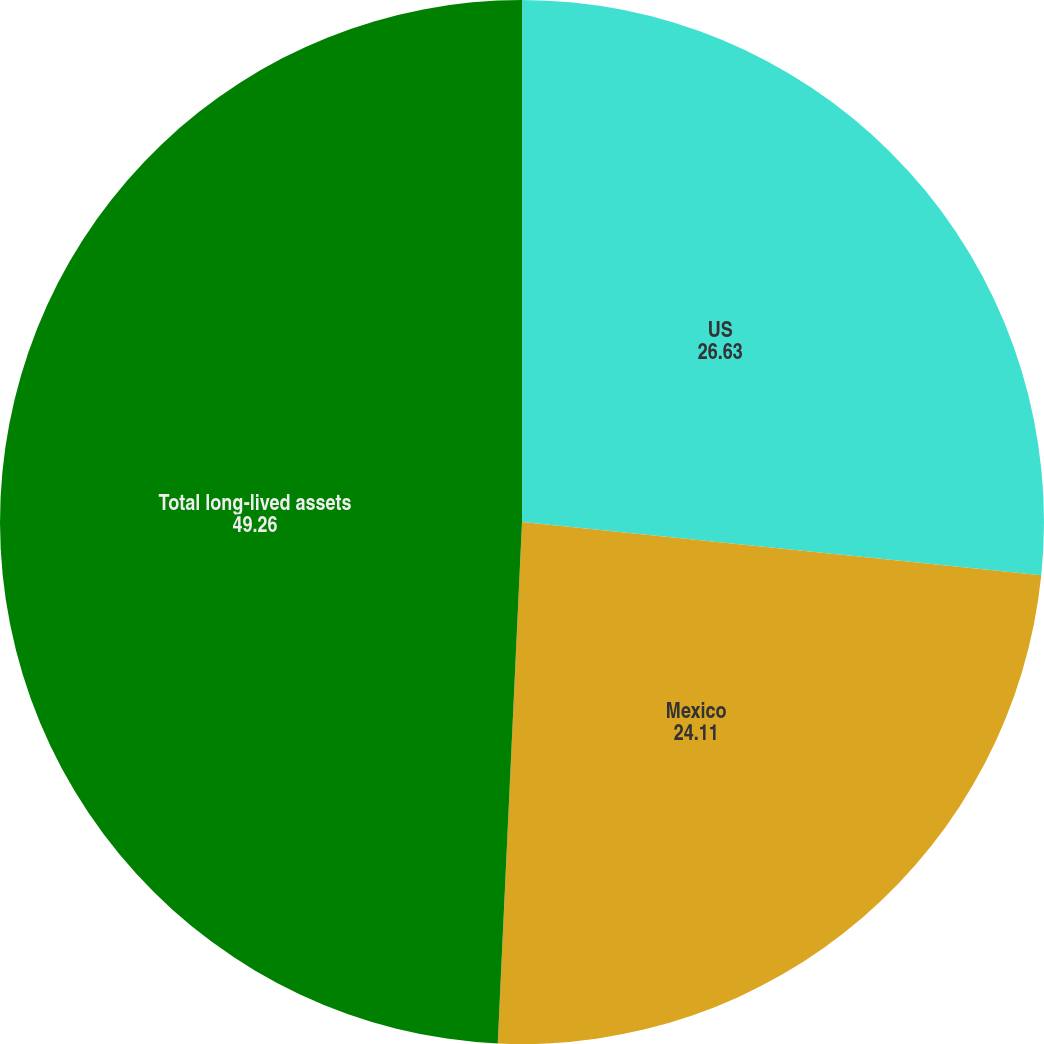<chart> <loc_0><loc_0><loc_500><loc_500><pie_chart><fcel>US<fcel>Mexico<fcel>Total long-lived assets<nl><fcel>26.63%<fcel>24.11%<fcel>49.26%<nl></chart> 